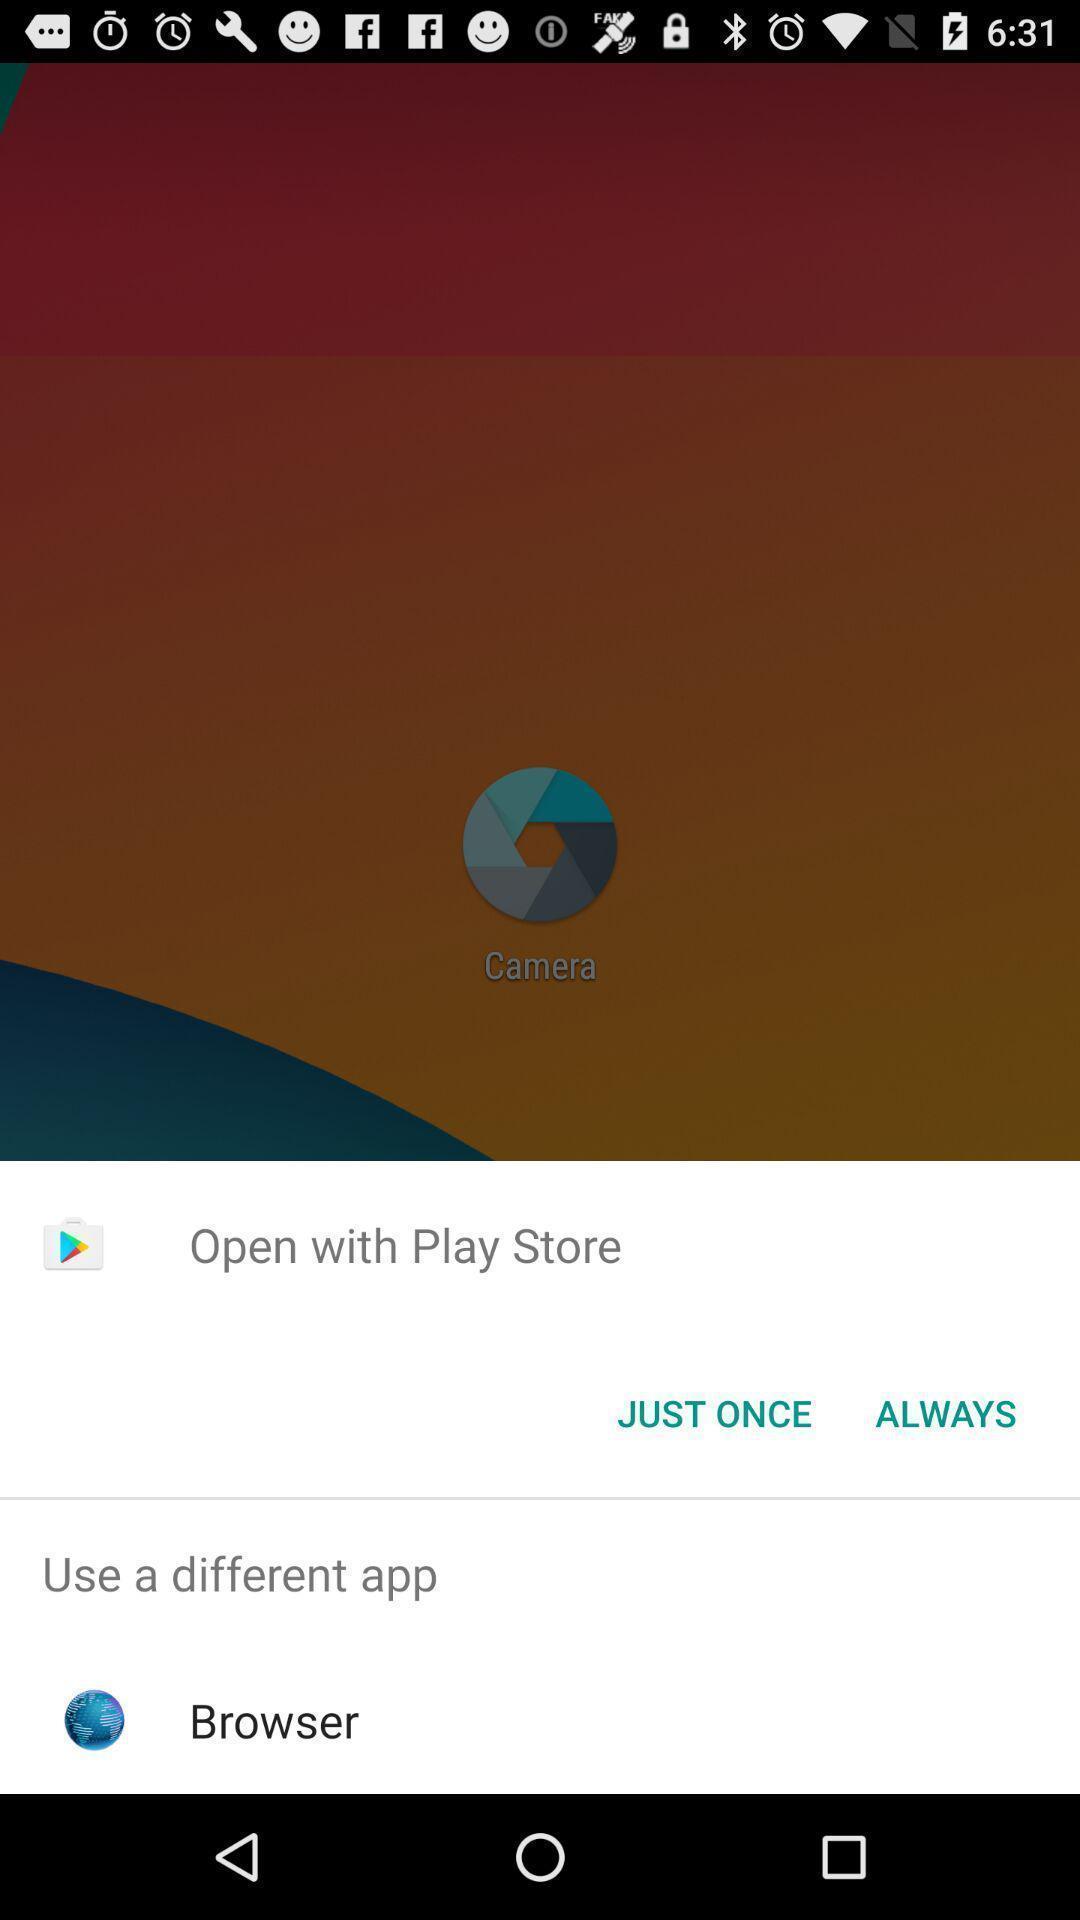Provide a detailed account of this screenshot. Popup of application to browse the net through it. 